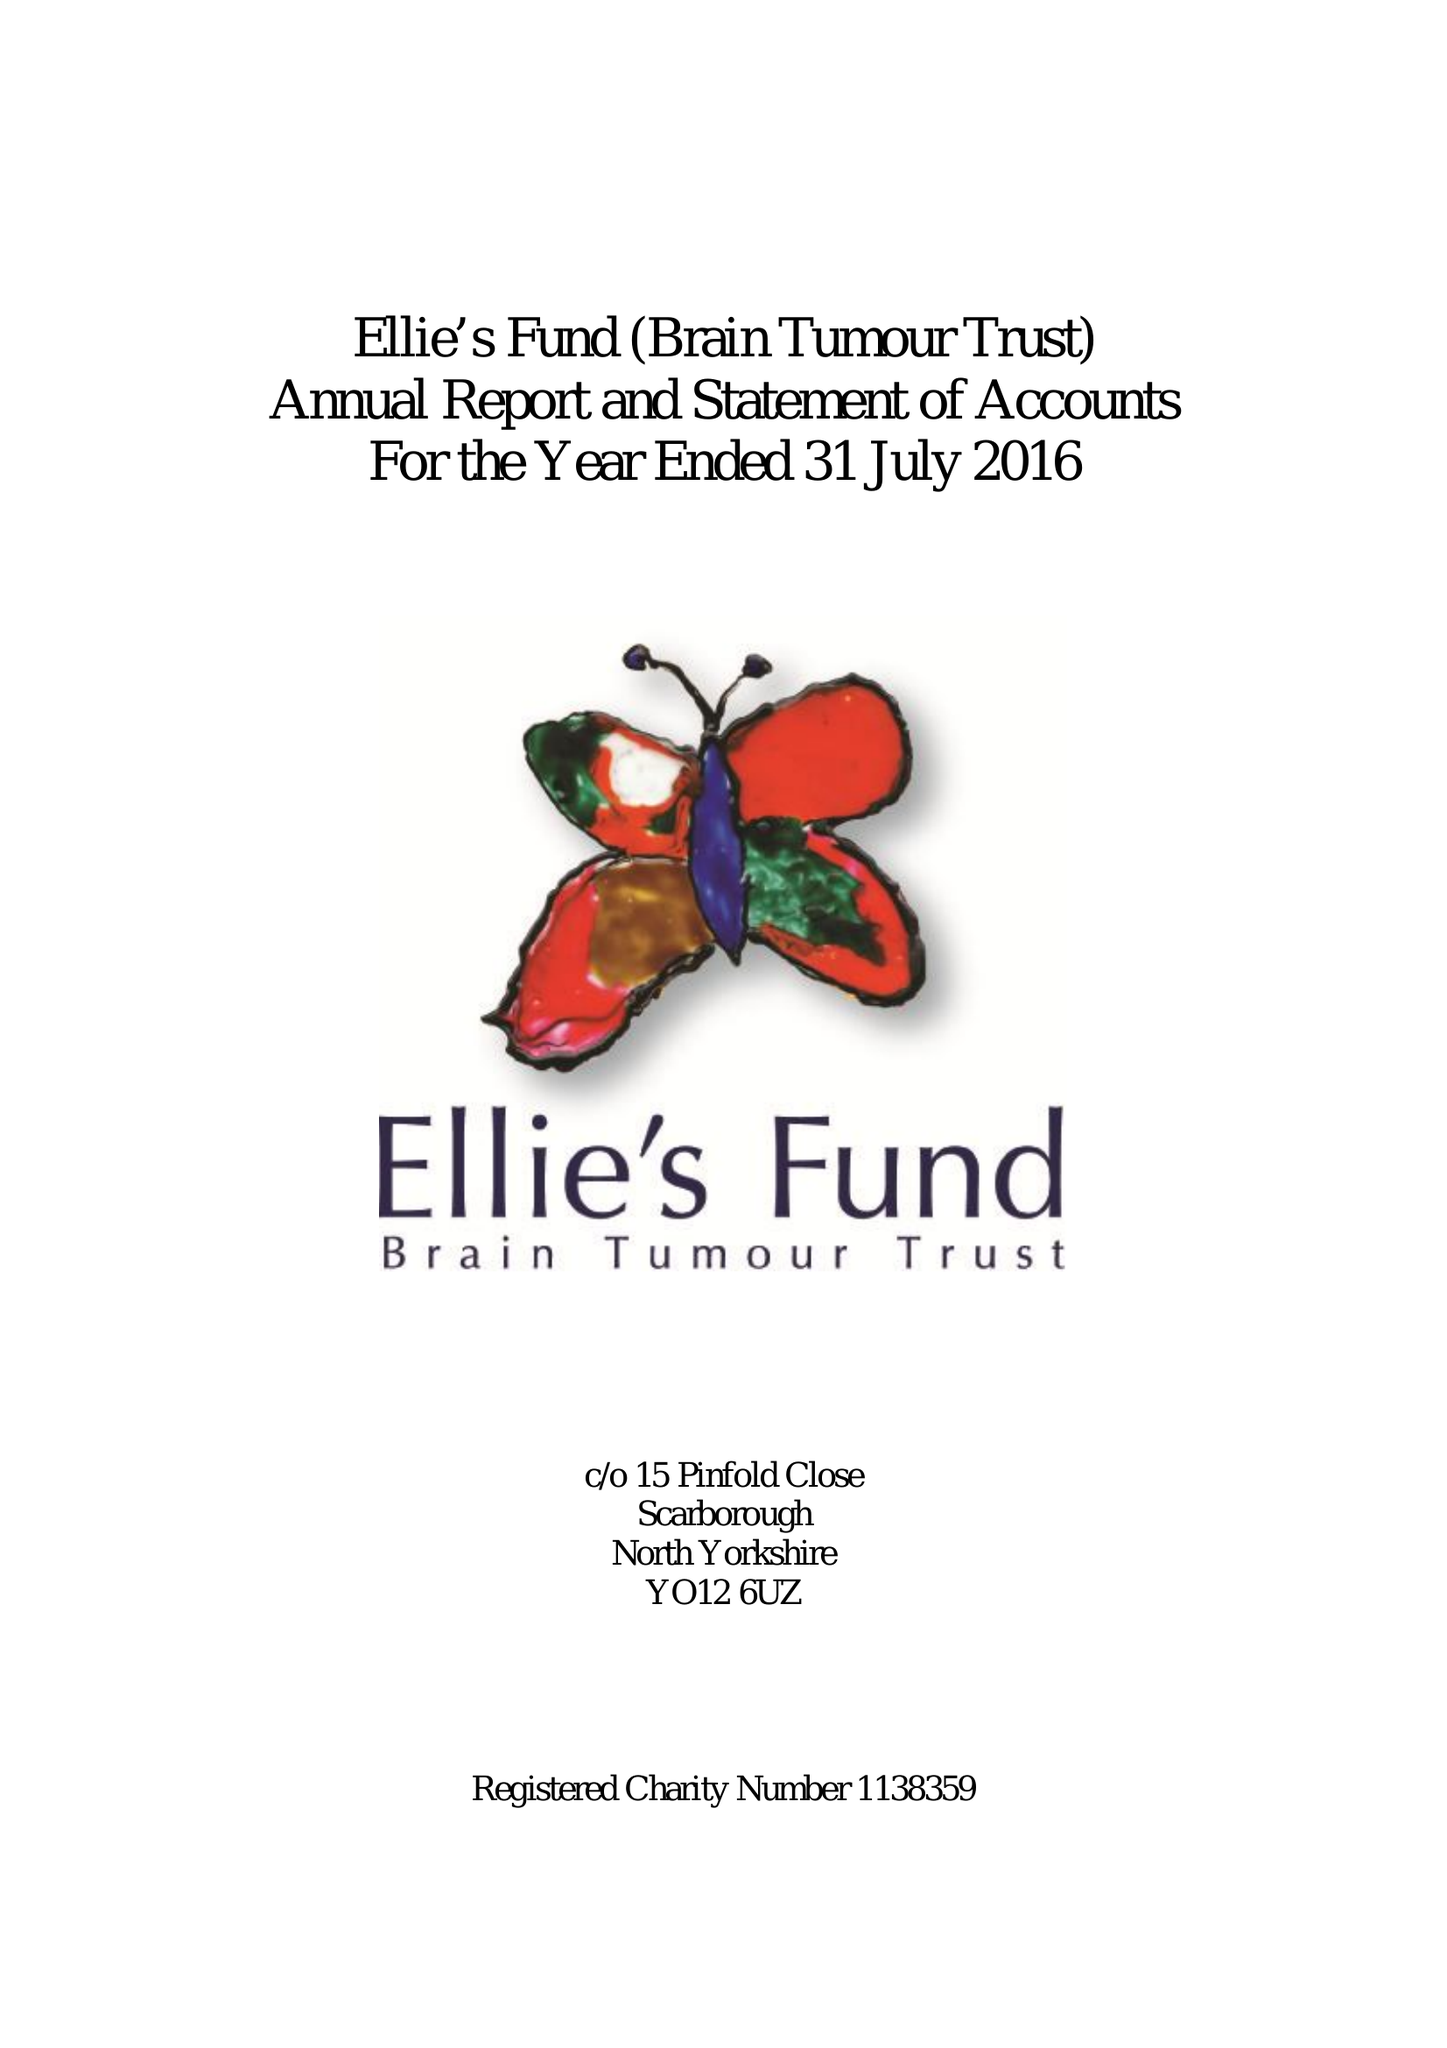What is the value for the address__postcode?
Answer the question using a single word or phrase. None 